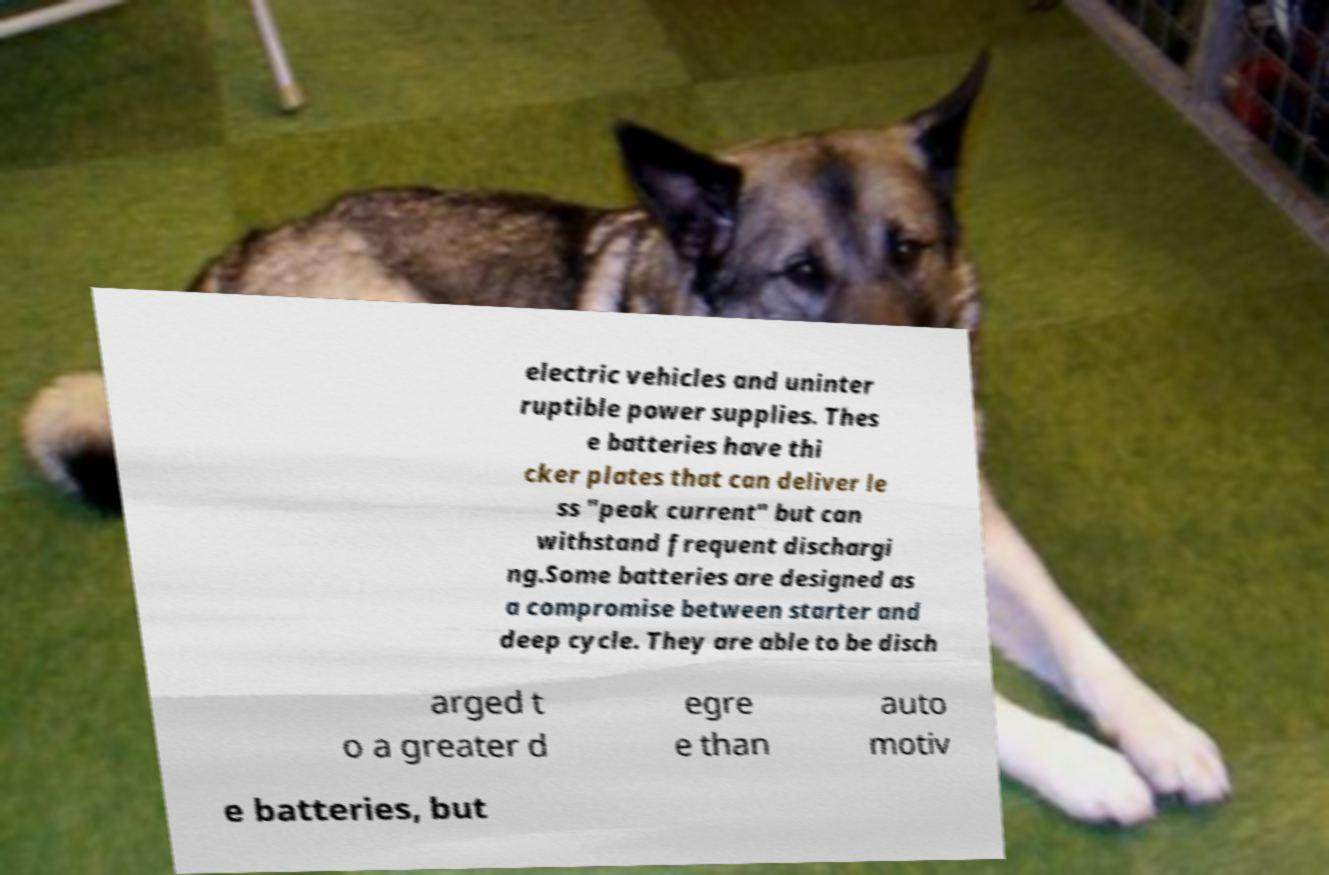Could you extract and type out the text from this image? electric vehicles and uninter ruptible power supplies. Thes e batteries have thi cker plates that can deliver le ss "peak current" but can withstand frequent dischargi ng.Some batteries are designed as a compromise between starter and deep cycle. They are able to be disch arged t o a greater d egre e than auto motiv e batteries, but 